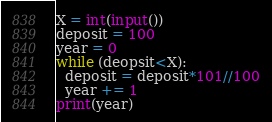<code> <loc_0><loc_0><loc_500><loc_500><_Python_>X = int(input())
deposit = 100
year = 0
while (deopsit<X):
  deposit = deposit*101//100
  year += 1
print(year)</code> 